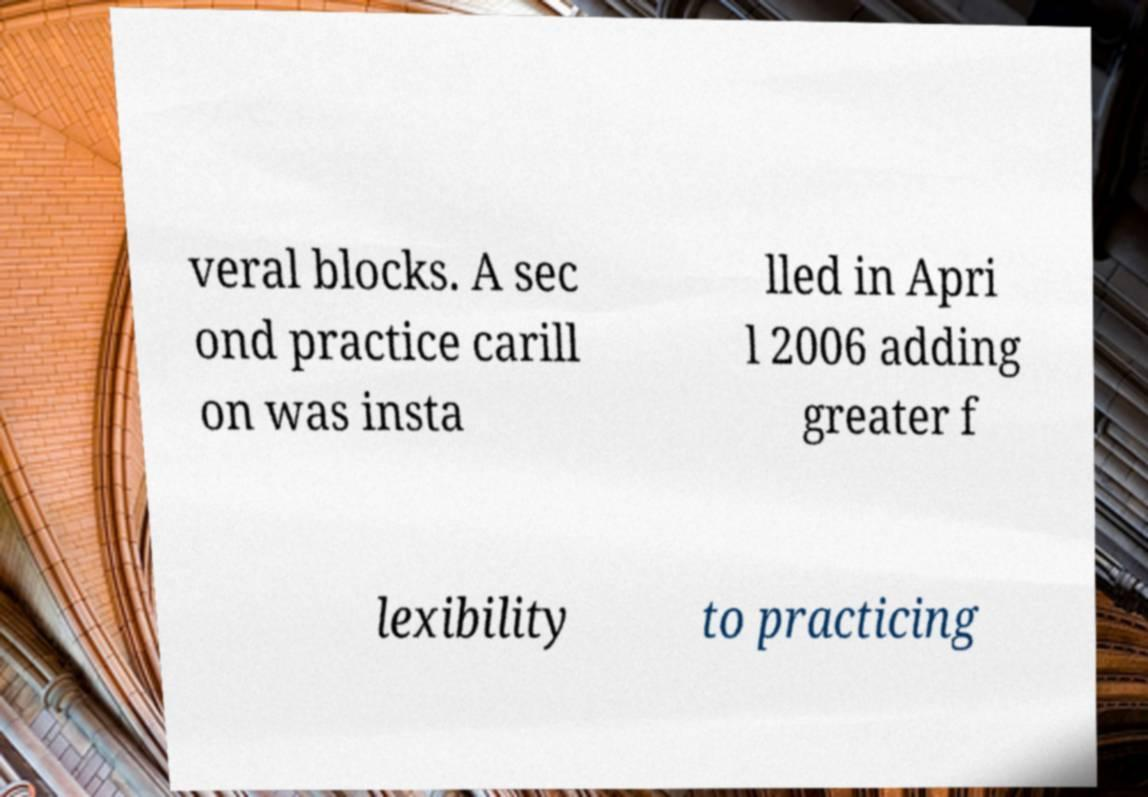Please identify and transcribe the text found in this image. veral blocks. A sec ond practice carill on was insta lled in Apri l 2006 adding greater f lexibility to practicing 